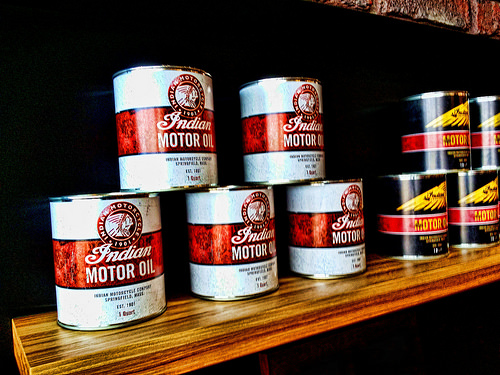<image>
Can you confirm if the oil can is on the oil can? Yes. Looking at the image, I can see the oil can is positioned on top of the oil can, with the oil can providing support. 